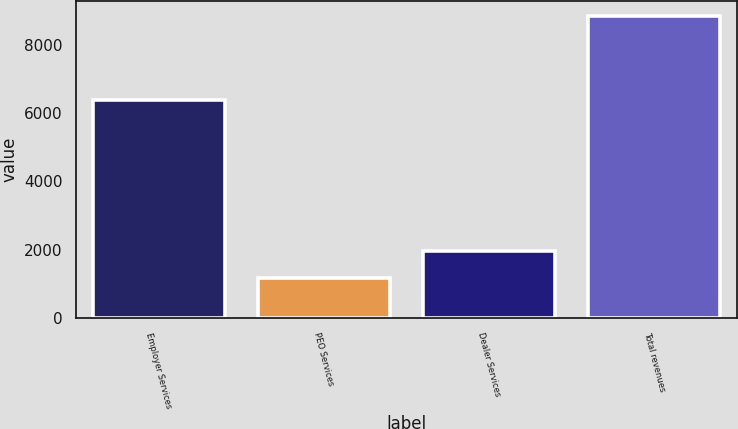Convert chart to OTSL. <chart><loc_0><loc_0><loc_500><loc_500><bar_chart><fcel>Employer Services<fcel>PEO Services<fcel>Dealer Services<fcel>Total revenues<nl><fcel>6378.6<fcel>1185.8<fcel>1951.06<fcel>8838.4<nl></chart> 